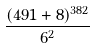<formula> <loc_0><loc_0><loc_500><loc_500>\frac { ( 4 9 1 + 8 ) ^ { 3 8 2 } } { 6 ^ { 2 } }</formula> 